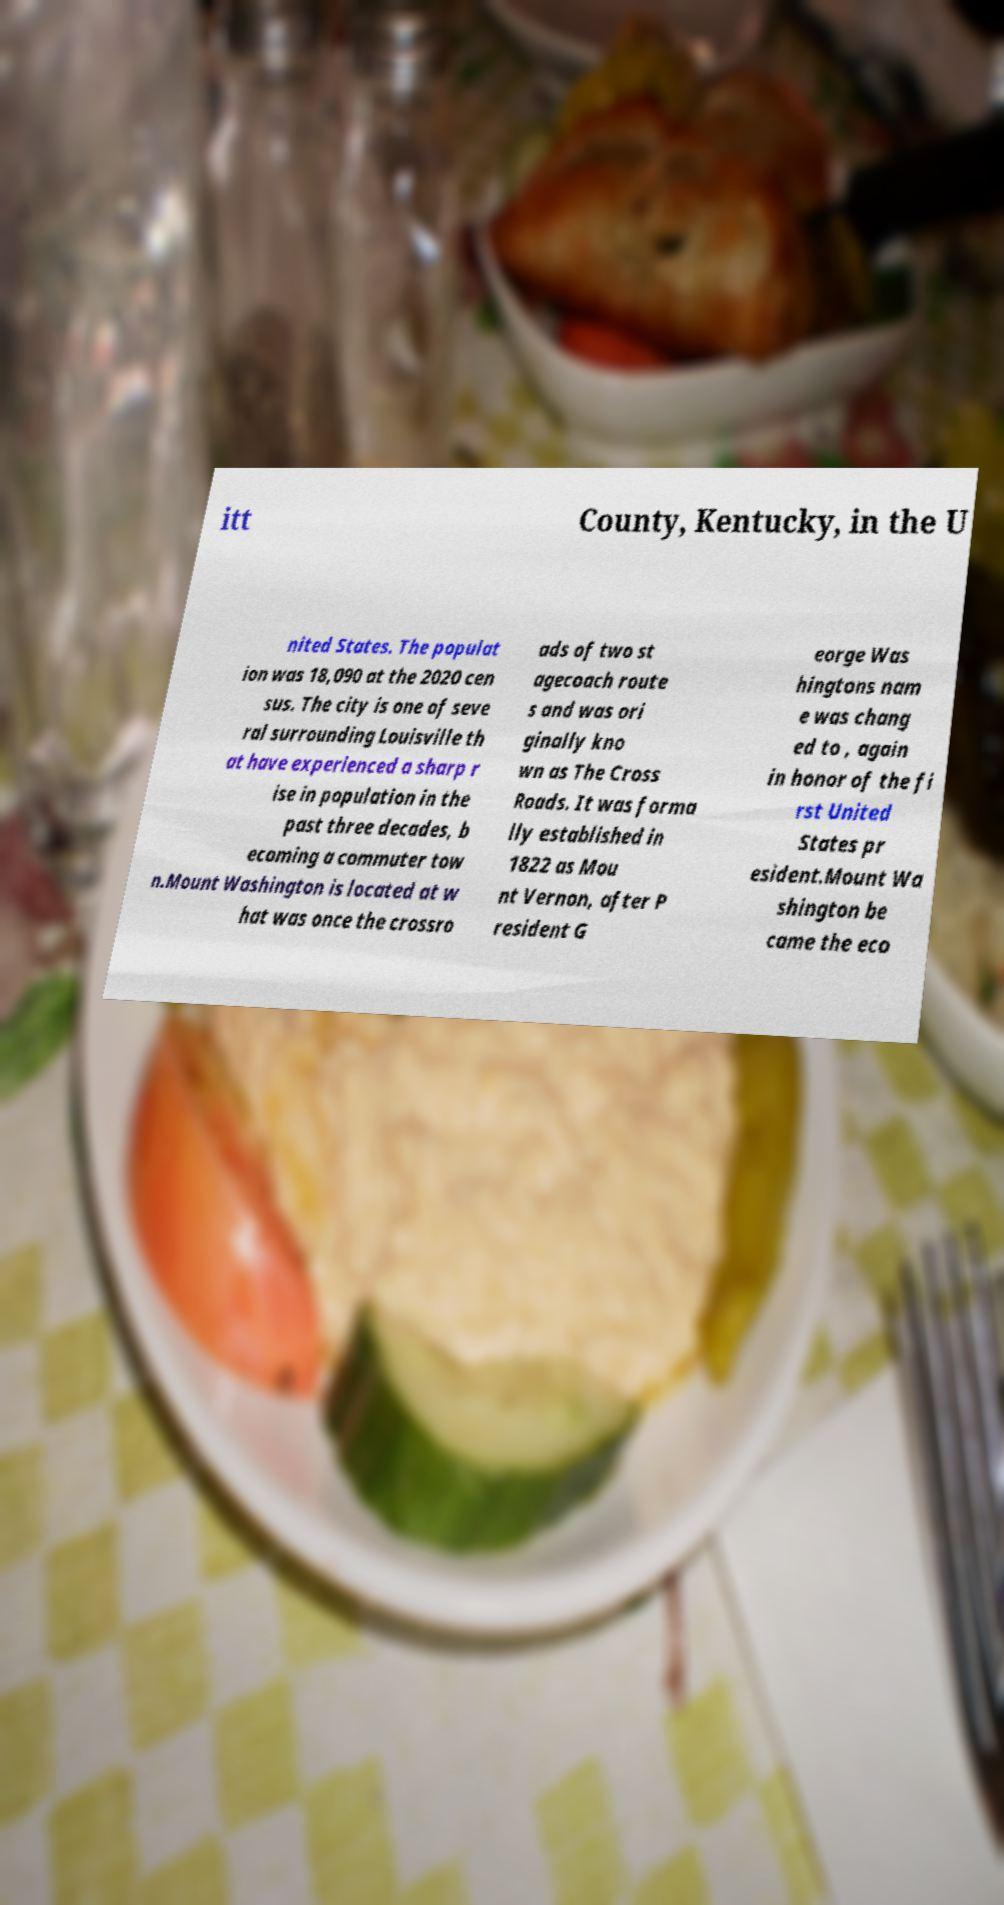I need the written content from this picture converted into text. Can you do that? itt County, Kentucky, in the U nited States. The populat ion was 18,090 at the 2020 cen sus. The city is one of seve ral surrounding Louisville th at have experienced a sharp r ise in population in the past three decades, b ecoming a commuter tow n.Mount Washington is located at w hat was once the crossro ads of two st agecoach route s and was ori ginally kno wn as The Cross Roads. It was forma lly established in 1822 as Mou nt Vernon, after P resident G eorge Was hingtons nam e was chang ed to , again in honor of the fi rst United States pr esident.Mount Wa shington be came the eco 